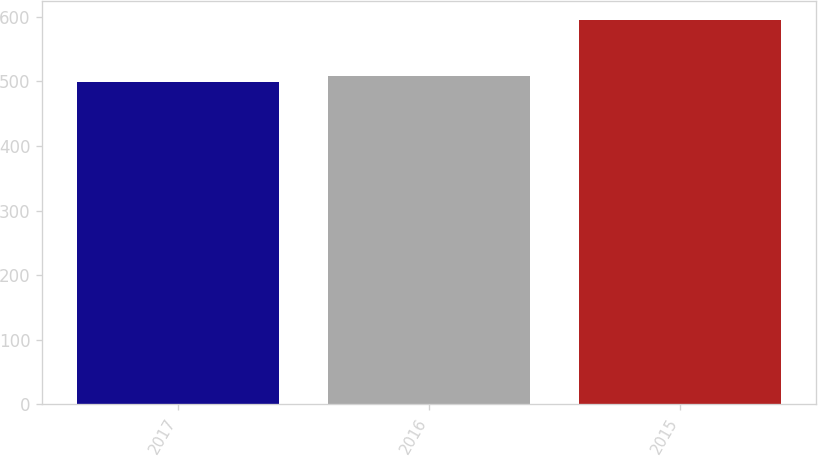<chart> <loc_0><loc_0><loc_500><loc_500><bar_chart><fcel>2017<fcel>2016<fcel>2015<nl><fcel>499<fcel>508.6<fcel>595<nl></chart> 